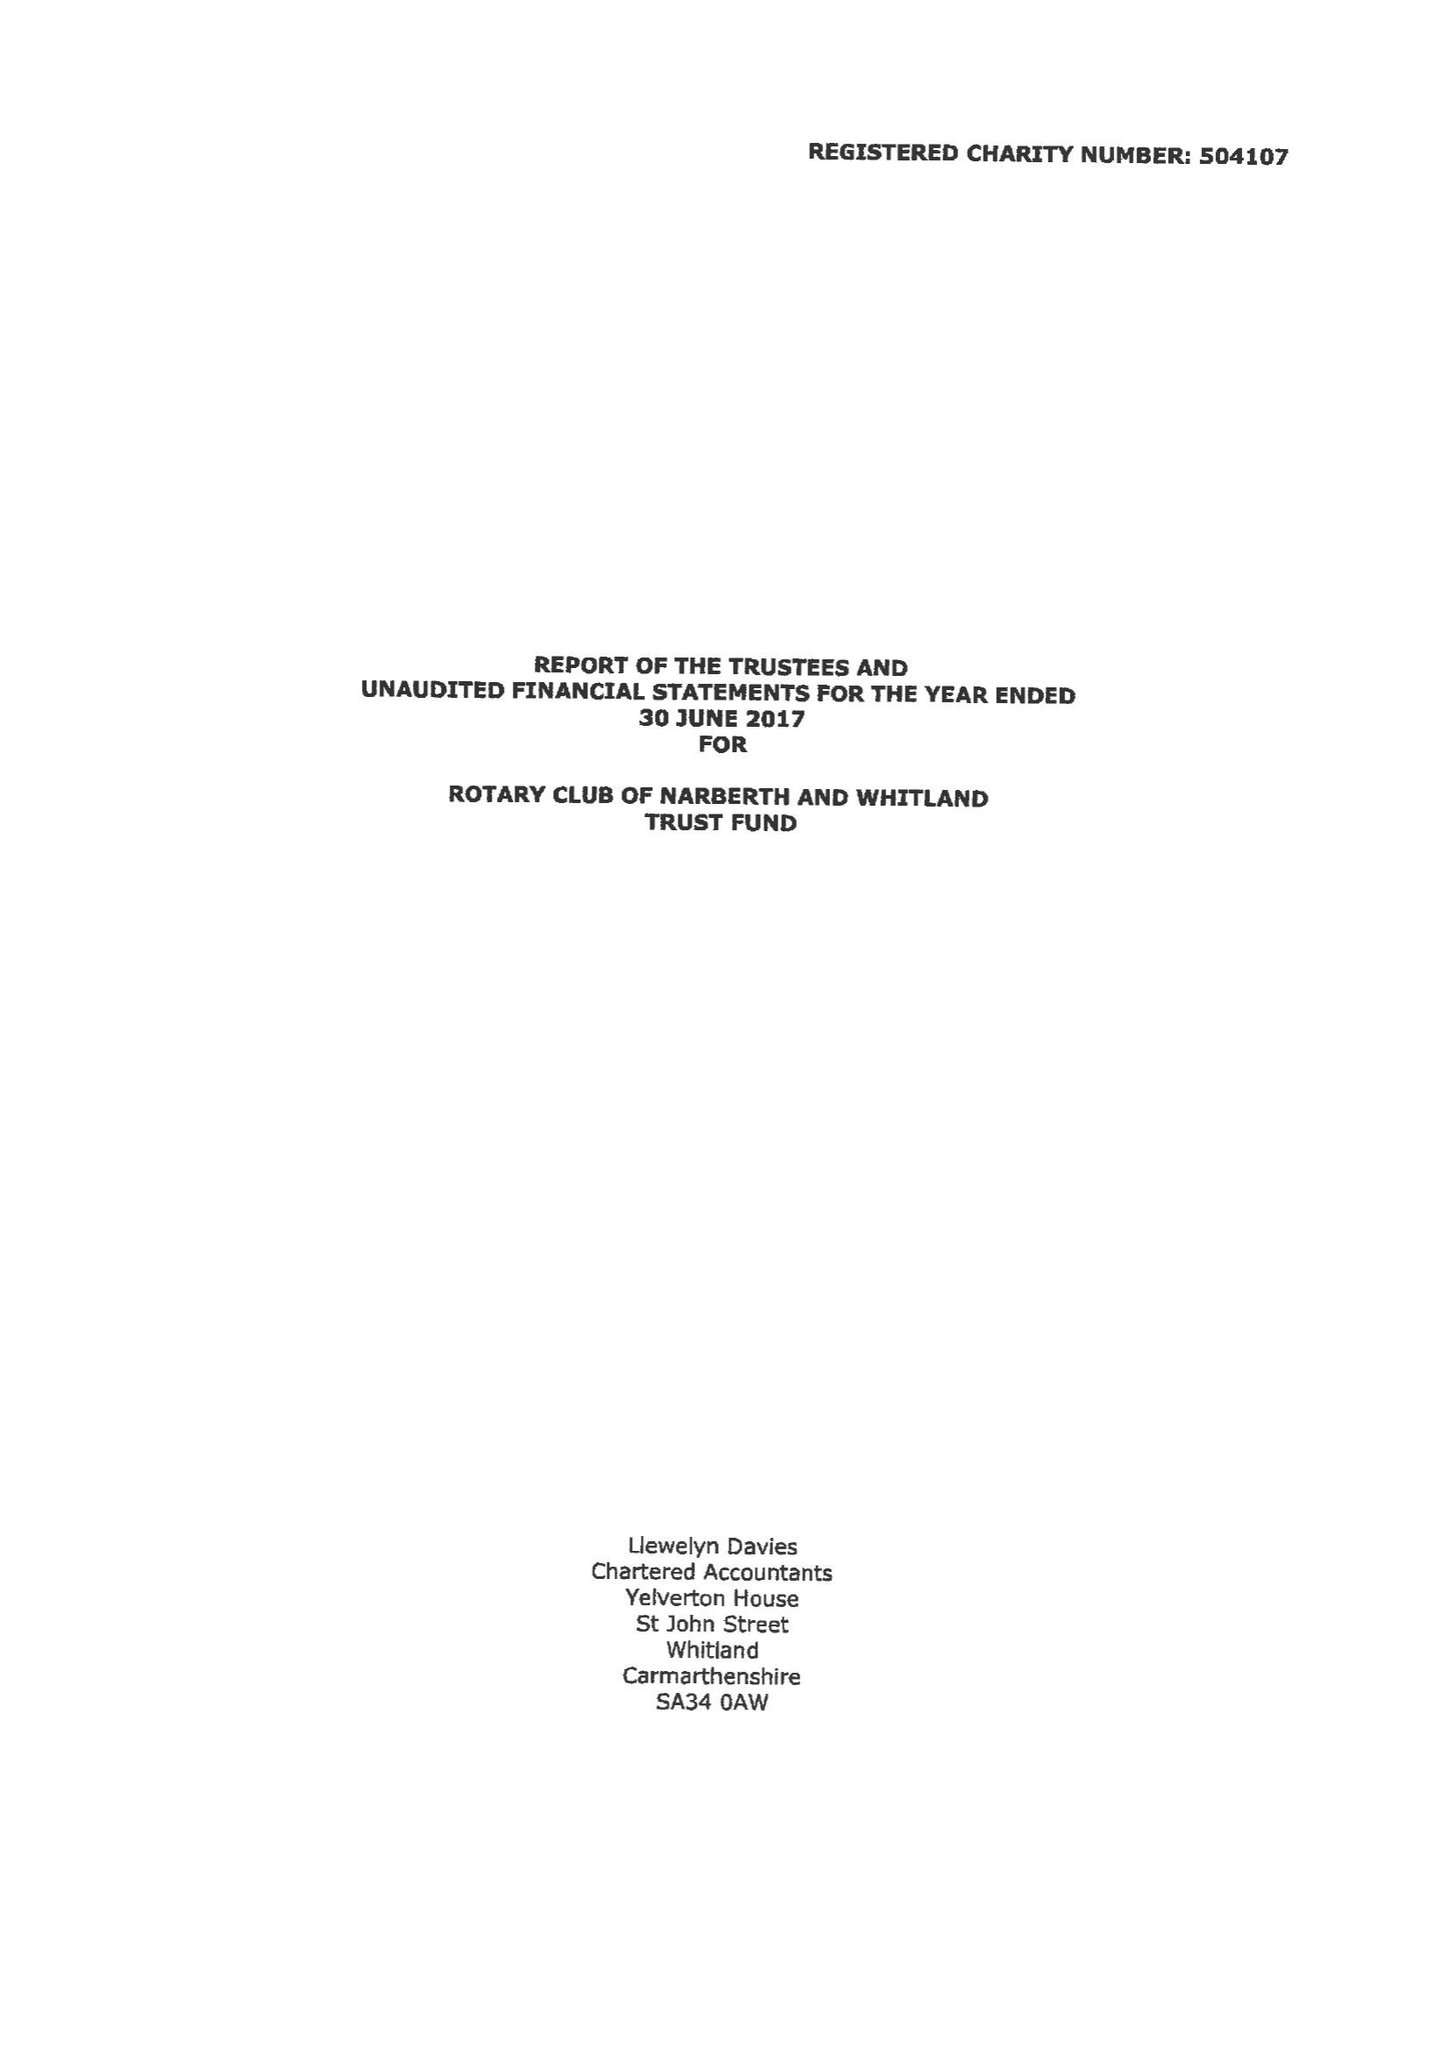What is the value for the charity_name?
Answer the question using a single word or phrase. Rotary Club Of Narberth and Whitland Trust Fund 